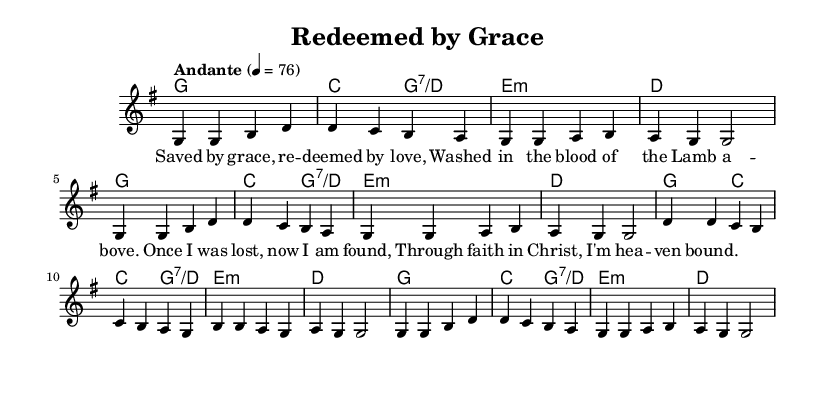What is the key signature of this music? The key signature is indicated at the beginning of the score. In this sheet music, we see a single sharp sign, which corresponds to the key of G major.
Answer: G major What is the time signature of this music? The time signature is represented at the beginning of the score. Here, it is noted as 4/4, indicating four beats per measure, and the quarter note receives one beat.
Answer: 4/4 What is the tempo marking of this piece? The tempo marking is specified in the score with the term “Andante,” which indicates a moderate pace. The metronome marking shows that the quarter note should be played at 76 beats per minute.
Answer: Andante How many measures are in this piece? To find the number of measures, we count the segments of music between the vertical lines on the staff. There are 12 measures total.
Answer: 12 What is the primary theme of the lyrics in this song? The lyrics center around themes of redemption, grace, and salvation through faith in Christ. By analyzing the content, it is clear the focus is on personal relationship with God and being saved.
Answer: Redemption and salvation What is the chord used in the first measure? The first measure contains the chord G major, which is identified by the note G as the root and is part of the harmonies provided in the score.
Answer: G What is the structure of the song based on the verses? The song is structured around repeated verses that convey a consistent message of being saved and found through faith. Analyzing the lyrics shows a repetitive nature, reinforcing the personal testimony of salvation.
Answer: Repetitive verses 